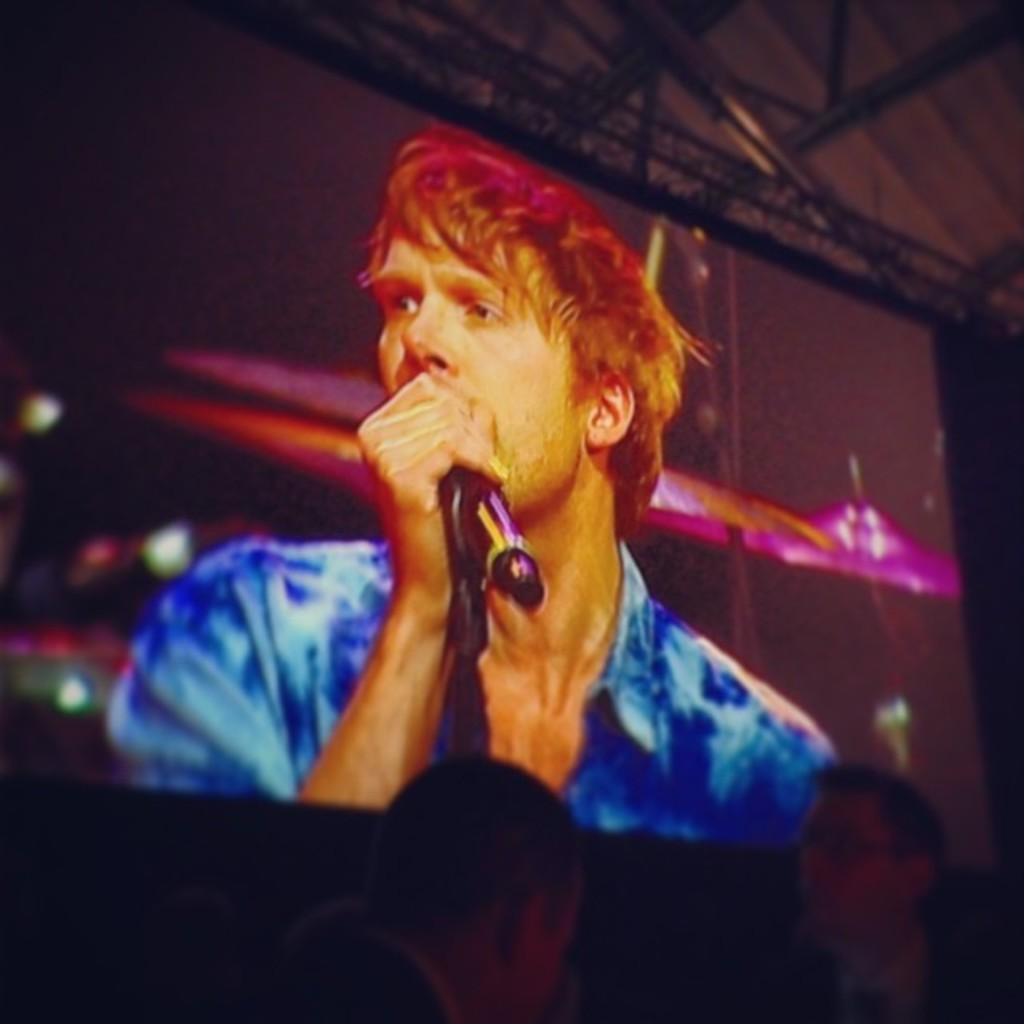Could you give a brief overview of what you see in this image? In the center of the image we can see a screen. On screen we can see a person is holding a mic. At the bottom of the image we can see some persons. At the top of the image we can see the roof and rods. 